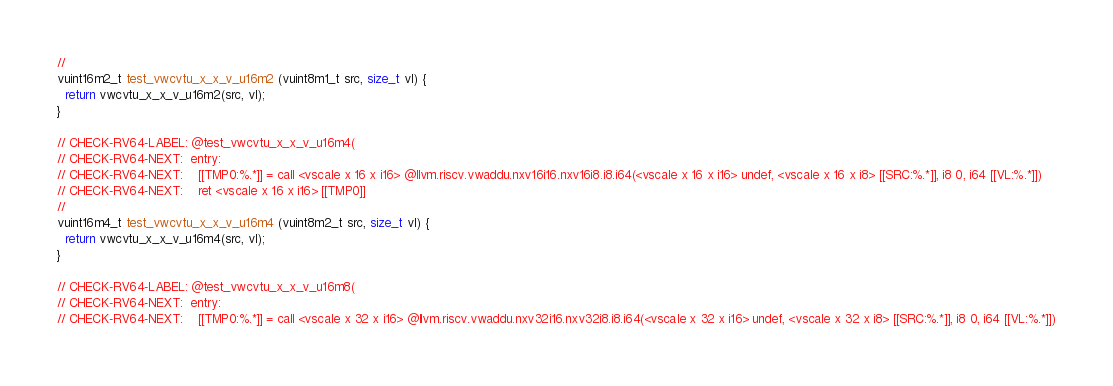Convert code to text. <code><loc_0><loc_0><loc_500><loc_500><_C_>//
vuint16m2_t test_vwcvtu_x_x_v_u16m2 (vuint8m1_t src, size_t vl) {
  return vwcvtu_x_x_v_u16m2(src, vl);
}

// CHECK-RV64-LABEL: @test_vwcvtu_x_x_v_u16m4(
// CHECK-RV64-NEXT:  entry:
// CHECK-RV64-NEXT:    [[TMP0:%.*]] = call <vscale x 16 x i16> @llvm.riscv.vwaddu.nxv16i16.nxv16i8.i8.i64(<vscale x 16 x i16> undef, <vscale x 16 x i8> [[SRC:%.*]], i8 0, i64 [[VL:%.*]])
// CHECK-RV64-NEXT:    ret <vscale x 16 x i16> [[TMP0]]
//
vuint16m4_t test_vwcvtu_x_x_v_u16m4 (vuint8m2_t src, size_t vl) {
  return vwcvtu_x_x_v_u16m4(src, vl);
}

// CHECK-RV64-LABEL: @test_vwcvtu_x_x_v_u16m8(
// CHECK-RV64-NEXT:  entry:
// CHECK-RV64-NEXT:    [[TMP0:%.*]] = call <vscale x 32 x i16> @llvm.riscv.vwaddu.nxv32i16.nxv32i8.i8.i64(<vscale x 32 x i16> undef, <vscale x 32 x i8> [[SRC:%.*]], i8 0, i64 [[VL:%.*]])</code> 